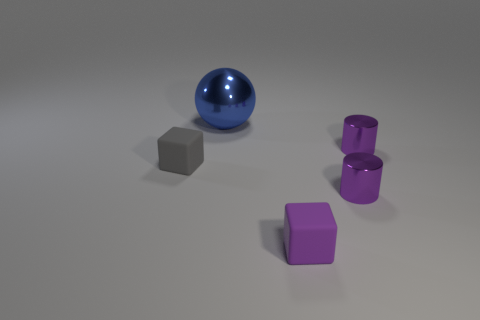What number of small blocks are the same color as the big object? Upon visual examination, there are no small blocks that match the color of the large spherical object. The big object is blue, and the small objects include one gray block and two purple cylinders. Therefore, the count of small blocks with the same color as the big object is zero. 